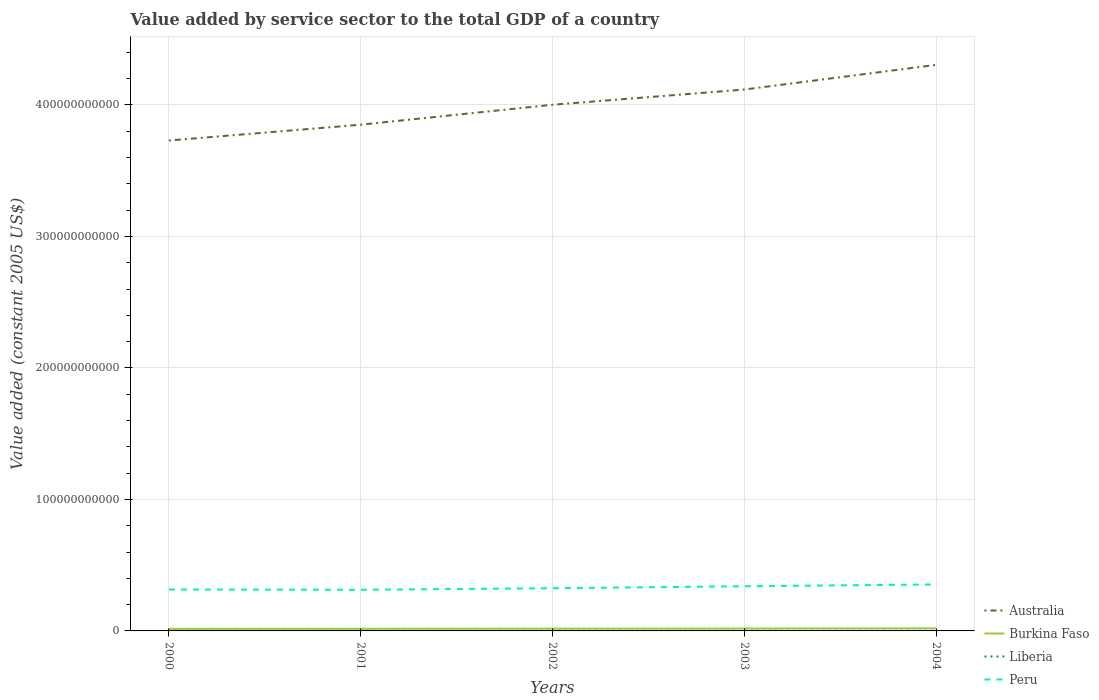Does the line corresponding to Peru intersect with the line corresponding to Australia?
Ensure brevity in your answer.  No. Is the number of lines equal to the number of legend labels?
Keep it short and to the point. Yes. Across all years, what is the maximum value added by service sector in Liberia?
Provide a succinct answer. 1.06e+08. In which year was the value added by service sector in Liberia maximum?
Your response must be concise. 2001. What is the total value added by service sector in Burkina Faso in the graph?
Offer a terse response. -5.86e+07. What is the difference between the highest and the second highest value added by service sector in Australia?
Offer a very short reply. 5.75e+1. How many lines are there?
Keep it short and to the point. 4. What is the difference between two consecutive major ticks on the Y-axis?
Ensure brevity in your answer.  1.00e+11. Are the values on the major ticks of Y-axis written in scientific E-notation?
Provide a succinct answer. No. Does the graph contain any zero values?
Offer a terse response. No. Does the graph contain grids?
Provide a short and direct response. Yes. Where does the legend appear in the graph?
Your answer should be compact. Bottom right. How many legend labels are there?
Your answer should be very brief. 4. How are the legend labels stacked?
Your answer should be compact. Vertical. What is the title of the graph?
Provide a short and direct response. Value added by service sector to the total GDP of a country. What is the label or title of the X-axis?
Your answer should be compact. Years. What is the label or title of the Y-axis?
Your answer should be compact. Value added (constant 2005 US$). What is the Value added (constant 2005 US$) in Australia in 2000?
Make the answer very short. 3.73e+11. What is the Value added (constant 2005 US$) of Burkina Faso in 2000?
Provide a short and direct response. 1.56e+09. What is the Value added (constant 2005 US$) in Liberia in 2000?
Your answer should be very brief. 1.07e+08. What is the Value added (constant 2005 US$) of Peru in 2000?
Offer a very short reply. 3.15e+1. What is the Value added (constant 2005 US$) in Australia in 2001?
Ensure brevity in your answer.  3.85e+11. What is the Value added (constant 2005 US$) of Burkina Faso in 2001?
Provide a short and direct response. 1.62e+09. What is the Value added (constant 2005 US$) in Liberia in 2001?
Provide a succinct answer. 1.06e+08. What is the Value added (constant 2005 US$) of Peru in 2001?
Offer a terse response. 3.13e+1. What is the Value added (constant 2005 US$) in Australia in 2002?
Ensure brevity in your answer.  4.00e+11. What is the Value added (constant 2005 US$) of Burkina Faso in 2002?
Provide a succinct answer. 1.76e+09. What is the Value added (constant 2005 US$) of Liberia in 2002?
Ensure brevity in your answer.  1.13e+08. What is the Value added (constant 2005 US$) in Peru in 2002?
Your answer should be very brief. 3.25e+1. What is the Value added (constant 2005 US$) in Australia in 2003?
Offer a terse response. 4.12e+11. What is the Value added (constant 2005 US$) in Burkina Faso in 2003?
Your response must be concise. 1.81e+09. What is the Value added (constant 2005 US$) in Liberia in 2003?
Your response must be concise. 1.11e+08. What is the Value added (constant 2005 US$) of Peru in 2003?
Make the answer very short. 3.40e+1. What is the Value added (constant 2005 US$) in Australia in 2004?
Ensure brevity in your answer.  4.31e+11. What is the Value added (constant 2005 US$) of Burkina Faso in 2004?
Provide a short and direct response. 1.97e+09. What is the Value added (constant 2005 US$) in Liberia in 2004?
Make the answer very short. 1.35e+08. What is the Value added (constant 2005 US$) in Peru in 2004?
Your answer should be compact. 3.53e+1. Across all years, what is the maximum Value added (constant 2005 US$) of Australia?
Keep it short and to the point. 4.31e+11. Across all years, what is the maximum Value added (constant 2005 US$) of Burkina Faso?
Provide a short and direct response. 1.97e+09. Across all years, what is the maximum Value added (constant 2005 US$) of Liberia?
Your answer should be compact. 1.35e+08. Across all years, what is the maximum Value added (constant 2005 US$) in Peru?
Ensure brevity in your answer.  3.53e+1. Across all years, what is the minimum Value added (constant 2005 US$) of Australia?
Make the answer very short. 3.73e+11. Across all years, what is the minimum Value added (constant 2005 US$) in Burkina Faso?
Your answer should be very brief. 1.56e+09. Across all years, what is the minimum Value added (constant 2005 US$) of Liberia?
Your response must be concise. 1.06e+08. Across all years, what is the minimum Value added (constant 2005 US$) of Peru?
Make the answer very short. 3.13e+1. What is the total Value added (constant 2005 US$) of Australia in the graph?
Offer a terse response. 2.00e+12. What is the total Value added (constant 2005 US$) in Burkina Faso in the graph?
Your answer should be compact. 8.73e+09. What is the total Value added (constant 2005 US$) of Liberia in the graph?
Offer a terse response. 5.72e+08. What is the total Value added (constant 2005 US$) of Peru in the graph?
Your answer should be very brief. 1.65e+11. What is the difference between the Value added (constant 2005 US$) in Australia in 2000 and that in 2001?
Your answer should be compact. -1.20e+1. What is the difference between the Value added (constant 2005 US$) in Burkina Faso in 2000 and that in 2001?
Provide a short and direct response. -5.86e+07. What is the difference between the Value added (constant 2005 US$) of Liberia in 2000 and that in 2001?
Keep it short and to the point. 1.25e+06. What is the difference between the Value added (constant 2005 US$) in Peru in 2000 and that in 2001?
Offer a terse response. 2.14e+08. What is the difference between the Value added (constant 2005 US$) of Australia in 2000 and that in 2002?
Ensure brevity in your answer.  -2.72e+1. What is the difference between the Value added (constant 2005 US$) in Burkina Faso in 2000 and that in 2002?
Make the answer very short. -1.97e+08. What is the difference between the Value added (constant 2005 US$) of Liberia in 2000 and that in 2002?
Your answer should be very brief. -6.06e+06. What is the difference between the Value added (constant 2005 US$) in Peru in 2000 and that in 2002?
Give a very brief answer. -9.56e+08. What is the difference between the Value added (constant 2005 US$) of Australia in 2000 and that in 2003?
Offer a very short reply. -3.88e+1. What is the difference between the Value added (constant 2005 US$) of Burkina Faso in 2000 and that in 2003?
Ensure brevity in your answer.  -2.41e+08. What is the difference between the Value added (constant 2005 US$) in Liberia in 2000 and that in 2003?
Your answer should be very brief. -4.32e+06. What is the difference between the Value added (constant 2005 US$) of Peru in 2000 and that in 2003?
Keep it short and to the point. -2.47e+09. What is the difference between the Value added (constant 2005 US$) of Australia in 2000 and that in 2004?
Ensure brevity in your answer.  -5.75e+1. What is the difference between the Value added (constant 2005 US$) in Burkina Faso in 2000 and that in 2004?
Offer a terse response. -4.10e+08. What is the difference between the Value added (constant 2005 US$) of Liberia in 2000 and that in 2004?
Keep it short and to the point. -2.82e+07. What is the difference between the Value added (constant 2005 US$) in Peru in 2000 and that in 2004?
Keep it short and to the point. -3.83e+09. What is the difference between the Value added (constant 2005 US$) of Australia in 2001 and that in 2002?
Your answer should be very brief. -1.52e+1. What is the difference between the Value added (constant 2005 US$) of Burkina Faso in 2001 and that in 2002?
Your answer should be very brief. -1.38e+08. What is the difference between the Value added (constant 2005 US$) in Liberia in 2001 and that in 2002?
Offer a terse response. -7.32e+06. What is the difference between the Value added (constant 2005 US$) of Peru in 2001 and that in 2002?
Provide a succinct answer. -1.17e+09. What is the difference between the Value added (constant 2005 US$) in Australia in 2001 and that in 2003?
Offer a very short reply. -2.67e+1. What is the difference between the Value added (constant 2005 US$) in Burkina Faso in 2001 and that in 2003?
Offer a terse response. -1.83e+08. What is the difference between the Value added (constant 2005 US$) of Liberia in 2001 and that in 2003?
Offer a terse response. -5.58e+06. What is the difference between the Value added (constant 2005 US$) of Peru in 2001 and that in 2003?
Offer a terse response. -2.69e+09. What is the difference between the Value added (constant 2005 US$) in Australia in 2001 and that in 2004?
Offer a very short reply. -4.55e+1. What is the difference between the Value added (constant 2005 US$) of Burkina Faso in 2001 and that in 2004?
Keep it short and to the point. -3.51e+08. What is the difference between the Value added (constant 2005 US$) in Liberia in 2001 and that in 2004?
Offer a very short reply. -2.94e+07. What is the difference between the Value added (constant 2005 US$) in Peru in 2001 and that in 2004?
Your answer should be compact. -4.05e+09. What is the difference between the Value added (constant 2005 US$) in Australia in 2002 and that in 2003?
Give a very brief answer. -1.16e+1. What is the difference between the Value added (constant 2005 US$) of Burkina Faso in 2002 and that in 2003?
Keep it short and to the point. -4.45e+07. What is the difference between the Value added (constant 2005 US$) in Liberia in 2002 and that in 2003?
Your answer should be compact. 1.74e+06. What is the difference between the Value added (constant 2005 US$) of Peru in 2002 and that in 2003?
Keep it short and to the point. -1.52e+09. What is the difference between the Value added (constant 2005 US$) of Australia in 2002 and that in 2004?
Provide a short and direct response. -3.03e+1. What is the difference between the Value added (constant 2005 US$) of Burkina Faso in 2002 and that in 2004?
Make the answer very short. -2.13e+08. What is the difference between the Value added (constant 2005 US$) of Liberia in 2002 and that in 2004?
Offer a terse response. -2.21e+07. What is the difference between the Value added (constant 2005 US$) in Peru in 2002 and that in 2004?
Ensure brevity in your answer.  -2.88e+09. What is the difference between the Value added (constant 2005 US$) of Australia in 2003 and that in 2004?
Give a very brief answer. -1.88e+1. What is the difference between the Value added (constant 2005 US$) of Burkina Faso in 2003 and that in 2004?
Your answer should be very brief. -1.68e+08. What is the difference between the Value added (constant 2005 US$) in Liberia in 2003 and that in 2004?
Keep it short and to the point. -2.39e+07. What is the difference between the Value added (constant 2005 US$) of Peru in 2003 and that in 2004?
Provide a succinct answer. -1.36e+09. What is the difference between the Value added (constant 2005 US$) in Australia in 2000 and the Value added (constant 2005 US$) in Burkina Faso in 2001?
Provide a short and direct response. 3.71e+11. What is the difference between the Value added (constant 2005 US$) in Australia in 2000 and the Value added (constant 2005 US$) in Liberia in 2001?
Provide a succinct answer. 3.73e+11. What is the difference between the Value added (constant 2005 US$) in Australia in 2000 and the Value added (constant 2005 US$) in Peru in 2001?
Make the answer very short. 3.42e+11. What is the difference between the Value added (constant 2005 US$) in Burkina Faso in 2000 and the Value added (constant 2005 US$) in Liberia in 2001?
Provide a short and direct response. 1.46e+09. What is the difference between the Value added (constant 2005 US$) in Burkina Faso in 2000 and the Value added (constant 2005 US$) in Peru in 2001?
Your response must be concise. -2.97e+1. What is the difference between the Value added (constant 2005 US$) in Liberia in 2000 and the Value added (constant 2005 US$) in Peru in 2001?
Provide a succinct answer. -3.12e+1. What is the difference between the Value added (constant 2005 US$) of Australia in 2000 and the Value added (constant 2005 US$) of Burkina Faso in 2002?
Provide a short and direct response. 3.71e+11. What is the difference between the Value added (constant 2005 US$) in Australia in 2000 and the Value added (constant 2005 US$) in Liberia in 2002?
Provide a succinct answer. 3.73e+11. What is the difference between the Value added (constant 2005 US$) of Australia in 2000 and the Value added (constant 2005 US$) of Peru in 2002?
Ensure brevity in your answer.  3.41e+11. What is the difference between the Value added (constant 2005 US$) of Burkina Faso in 2000 and the Value added (constant 2005 US$) of Liberia in 2002?
Offer a very short reply. 1.45e+09. What is the difference between the Value added (constant 2005 US$) in Burkina Faso in 2000 and the Value added (constant 2005 US$) in Peru in 2002?
Ensure brevity in your answer.  -3.09e+1. What is the difference between the Value added (constant 2005 US$) in Liberia in 2000 and the Value added (constant 2005 US$) in Peru in 2002?
Provide a short and direct response. -3.24e+1. What is the difference between the Value added (constant 2005 US$) of Australia in 2000 and the Value added (constant 2005 US$) of Burkina Faso in 2003?
Your response must be concise. 3.71e+11. What is the difference between the Value added (constant 2005 US$) of Australia in 2000 and the Value added (constant 2005 US$) of Liberia in 2003?
Offer a terse response. 3.73e+11. What is the difference between the Value added (constant 2005 US$) in Australia in 2000 and the Value added (constant 2005 US$) in Peru in 2003?
Give a very brief answer. 3.39e+11. What is the difference between the Value added (constant 2005 US$) in Burkina Faso in 2000 and the Value added (constant 2005 US$) in Liberia in 2003?
Offer a very short reply. 1.45e+09. What is the difference between the Value added (constant 2005 US$) of Burkina Faso in 2000 and the Value added (constant 2005 US$) of Peru in 2003?
Offer a very short reply. -3.24e+1. What is the difference between the Value added (constant 2005 US$) in Liberia in 2000 and the Value added (constant 2005 US$) in Peru in 2003?
Provide a succinct answer. -3.39e+1. What is the difference between the Value added (constant 2005 US$) in Australia in 2000 and the Value added (constant 2005 US$) in Burkina Faso in 2004?
Ensure brevity in your answer.  3.71e+11. What is the difference between the Value added (constant 2005 US$) of Australia in 2000 and the Value added (constant 2005 US$) of Liberia in 2004?
Your response must be concise. 3.73e+11. What is the difference between the Value added (constant 2005 US$) in Australia in 2000 and the Value added (constant 2005 US$) in Peru in 2004?
Your response must be concise. 3.38e+11. What is the difference between the Value added (constant 2005 US$) in Burkina Faso in 2000 and the Value added (constant 2005 US$) in Liberia in 2004?
Ensure brevity in your answer.  1.43e+09. What is the difference between the Value added (constant 2005 US$) in Burkina Faso in 2000 and the Value added (constant 2005 US$) in Peru in 2004?
Offer a very short reply. -3.38e+1. What is the difference between the Value added (constant 2005 US$) in Liberia in 2000 and the Value added (constant 2005 US$) in Peru in 2004?
Ensure brevity in your answer.  -3.52e+1. What is the difference between the Value added (constant 2005 US$) in Australia in 2001 and the Value added (constant 2005 US$) in Burkina Faso in 2002?
Provide a succinct answer. 3.83e+11. What is the difference between the Value added (constant 2005 US$) of Australia in 2001 and the Value added (constant 2005 US$) of Liberia in 2002?
Make the answer very short. 3.85e+11. What is the difference between the Value added (constant 2005 US$) in Australia in 2001 and the Value added (constant 2005 US$) in Peru in 2002?
Ensure brevity in your answer.  3.53e+11. What is the difference between the Value added (constant 2005 US$) of Burkina Faso in 2001 and the Value added (constant 2005 US$) of Liberia in 2002?
Make the answer very short. 1.51e+09. What is the difference between the Value added (constant 2005 US$) of Burkina Faso in 2001 and the Value added (constant 2005 US$) of Peru in 2002?
Make the answer very short. -3.08e+1. What is the difference between the Value added (constant 2005 US$) in Liberia in 2001 and the Value added (constant 2005 US$) in Peru in 2002?
Make the answer very short. -3.24e+1. What is the difference between the Value added (constant 2005 US$) in Australia in 2001 and the Value added (constant 2005 US$) in Burkina Faso in 2003?
Your answer should be very brief. 3.83e+11. What is the difference between the Value added (constant 2005 US$) in Australia in 2001 and the Value added (constant 2005 US$) in Liberia in 2003?
Offer a very short reply. 3.85e+11. What is the difference between the Value added (constant 2005 US$) of Australia in 2001 and the Value added (constant 2005 US$) of Peru in 2003?
Offer a very short reply. 3.51e+11. What is the difference between the Value added (constant 2005 US$) in Burkina Faso in 2001 and the Value added (constant 2005 US$) in Liberia in 2003?
Ensure brevity in your answer.  1.51e+09. What is the difference between the Value added (constant 2005 US$) in Burkina Faso in 2001 and the Value added (constant 2005 US$) in Peru in 2003?
Your response must be concise. -3.24e+1. What is the difference between the Value added (constant 2005 US$) in Liberia in 2001 and the Value added (constant 2005 US$) in Peru in 2003?
Make the answer very short. -3.39e+1. What is the difference between the Value added (constant 2005 US$) in Australia in 2001 and the Value added (constant 2005 US$) in Burkina Faso in 2004?
Provide a succinct answer. 3.83e+11. What is the difference between the Value added (constant 2005 US$) of Australia in 2001 and the Value added (constant 2005 US$) of Liberia in 2004?
Your answer should be very brief. 3.85e+11. What is the difference between the Value added (constant 2005 US$) of Australia in 2001 and the Value added (constant 2005 US$) of Peru in 2004?
Offer a very short reply. 3.50e+11. What is the difference between the Value added (constant 2005 US$) of Burkina Faso in 2001 and the Value added (constant 2005 US$) of Liberia in 2004?
Offer a very short reply. 1.49e+09. What is the difference between the Value added (constant 2005 US$) of Burkina Faso in 2001 and the Value added (constant 2005 US$) of Peru in 2004?
Ensure brevity in your answer.  -3.37e+1. What is the difference between the Value added (constant 2005 US$) in Liberia in 2001 and the Value added (constant 2005 US$) in Peru in 2004?
Provide a succinct answer. -3.52e+1. What is the difference between the Value added (constant 2005 US$) in Australia in 2002 and the Value added (constant 2005 US$) in Burkina Faso in 2003?
Make the answer very short. 3.98e+11. What is the difference between the Value added (constant 2005 US$) in Australia in 2002 and the Value added (constant 2005 US$) in Liberia in 2003?
Offer a terse response. 4.00e+11. What is the difference between the Value added (constant 2005 US$) of Australia in 2002 and the Value added (constant 2005 US$) of Peru in 2003?
Your answer should be compact. 3.66e+11. What is the difference between the Value added (constant 2005 US$) in Burkina Faso in 2002 and the Value added (constant 2005 US$) in Liberia in 2003?
Give a very brief answer. 1.65e+09. What is the difference between the Value added (constant 2005 US$) in Burkina Faso in 2002 and the Value added (constant 2005 US$) in Peru in 2003?
Ensure brevity in your answer.  -3.22e+1. What is the difference between the Value added (constant 2005 US$) of Liberia in 2002 and the Value added (constant 2005 US$) of Peru in 2003?
Offer a very short reply. -3.39e+1. What is the difference between the Value added (constant 2005 US$) of Australia in 2002 and the Value added (constant 2005 US$) of Burkina Faso in 2004?
Your answer should be very brief. 3.98e+11. What is the difference between the Value added (constant 2005 US$) of Australia in 2002 and the Value added (constant 2005 US$) of Liberia in 2004?
Provide a succinct answer. 4.00e+11. What is the difference between the Value added (constant 2005 US$) of Australia in 2002 and the Value added (constant 2005 US$) of Peru in 2004?
Offer a terse response. 3.65e+11. What is the difference between the Value added (constant 2005 US$) in Burkina Faso in 2002 and the Value added (constant 2005 US$) in Liberia in 2004?
Give a very brief answer. 1.63e+09. What is the difference between the Value added (constant 2005 US$) of Burkina Faso in 2002 and the Value added (constant 2005 US$) of Peru in 2004?
Keep it short and to the point. -3.36e+1. What is the difference between the Value added (constant 2005 US$) in Liberia in 2002 and the Value added (constant 2005 US$) in Peru in 2004?
Provide a succinct answer. -3.52e+1. What is the difference between the Value added (constant 2005 US$) of Australia in 2003 and the Value added (constant 2005 US$) of Burkina Faso in 2004?
Provide a succinct answer. 4.10e+11. What is the difference between the Value added (constant 2005 US$) of Australia in 2003 and the Value added (constant 2005 US$) of Liberia in 2004?
Your answer should be compact. 4.12e+11. What is the difference between the Value added (constant 2005 US$) in Australia in 2003 and the Value added (constant 2005 US$) in Peru in 2004?
Ensure brevity in your answer.  3.76e+11. What is the difference between the Value added (constant 2005 US$) in Burkina Faso in 2003 and the Value added (constant 2005 US$) in Liberia in 2004?
Your answer should be very brief. 1.67e+09. What is the difference between the Value added (constant 2005 US$) in Burkina Faso in 2003 and the Value added (constant 2005 US$) in Peru in 2004?
Ensure brevity in your answer.  -3.35e+1. What is the difference between the Value added (constant 2005 US$) in Liberia in 2003 and the Value added (constant 2005 US$) in Peru in 2004?
Provide a succinct answer. -3.52e+1. What is the average Value added (constant 2005 US$) of Australia per year?
Your answer should be compact. 4.00e+11. What is the average Value added (constant 2005 US$) of Burkina Faso per year?
Offer a very short reply. 1.75e+09. What is the average Value added (constant 2005 US$) of Liberia per year?
Give a very brief answer. 1.14e+08. What is the average Value added (constant 2005 US$) in Peru per year?
Your answer should be very brief. 3.29e+1. In the year 2000, what is the difference between the Value added (constant 2005 US$) in Australia and Value added (constant 2005 US$) in Burkina Faso?
Make the answer very short. 3.71e+11. In the year 2000, what is the difference between the Value added (constant 2005 US$) in Australia and Value added (constant 2005 US$) in Liberia?
Your answer should be compact. 3.73e+11. In the year 2000, what is the difference between the Value added (constant 2005 US$) of Australia and Value added (constant 2005 US$) of Peru?
Offer a very short reply. 3.41e+11. In the year 2000, what is the difference between the Value added (constant 2005 US$) of Burkina Faso and Value added (constant 2005 US$) of Liberia?
Keep it short and to the point. 1.46e+09. In the year 2000, what is the difference between the Value added (constant 2005 US$) in Burkina Faso and Value added (constant 2005 US$) in Peru?
Your answer should be very brief. -2.99e+1. In the year 2000, what is the difference between the Value added (constant 2005 US$) of Liberia and Value added (constant 2005 US$) of Peru?
Provide a short and direct response. -3.14e+1. In the year 2001, what is the difference between the Value added (constant 2005 US$) in Australia and Value added (constant 2005 US$) in Burkina Faso?
Your answer should be very brief. 3.83e+11. In the year 2001, what is the difference between the Value added (constant 2005 US$) of Australia and Value added (constant 2005 US$) of Liberia?
Ensure brevity in your answer.  3.85e+11. In the year 2001, what is the difference between the Value added (constant 2005 US$) of Australia and Value added (constant 2005 US$) of Peru?
Your answer should be very brief. 3.54e+11. In the year 2001, what is the difference between the Value added (constant 2005 US$) of Burkina Faso and Value added (constant 2005 US$) of Liberia?
Ensure brevity in your answer.  1.52e+09. In the year 2001, what is the difference between the Value added (constant 2005 US$) in Burkina Faso and Value added (constant 2005 US$) in Peru?
Your response must be concise. -2.97e+1. In the year 2001, what is the difference between the Value added (constant 2005 US$) in Liberia and Value added (constant 2005 US$) in Peru?
Keep it short and to the point. -3.12e+1. In the year 2002, what is the difference between the Value added (constant 2005 US$) of Australia and Value added (constant 2005 US$) of Burkina Faso?
Give a very brief answer. 3.98e+11. In the year 2002, what is the difference between the Value added (constant 2005 US$) of Australia and Value added (constant 2005 US$) of Liberia?
Offer a terse response. 4.00e+11. In the year 2002, what is the difference between the Value added (constant 2005 US$) of Australia and Value added (constant 2005 US$) of Peru?
Your answer should be compact. 3.68e+11. In the year 2002, what is the difference between the Value added (constant 2005 US$) of Burkina Faso and Value added (constant 2005 US$) of Liberia?
Offer a terse response. 1.65e+09. In the year 2002, what is the difference between the Value added (constant 2005 US$) of Burkina Faso and Value added (constant 2005 US$) of Peru?
Your response must be concise. -3.07e+1. In the year 2002, what is the difference between the Value added (constant 2005 US$) of Liberia and Value added (constant 2005 US$) of Peru?
Your response must be concise. -3.23e+1. In the year 2003, what is the difference between the Value added (constant 2005 US$) of Australia and Value added (constant 2005 US$) of Burkina Faso?
Provide a short and direct response. 4.10e+11. In the year 2003, what is the difference between the Value added (constant 2005 US$) in Australia and Value added (constant 2005 US$) in Liberia?
Offer a very short reply. 4.12e+11. In the year 2003, what is the difference between the Value added (constant 2005 US$) of Australia and Value added (constant 2005 US$) of Peru?
Ensure brevity in your answer.  3.78e+11. In the year 2003, what is the difference between the Value added (constant 2005 US$) in Burkina Faso and Value added (constant 2005 US$) in Liberia?
Your answer should be compact. 1.69e+09. In the year 2003, what is the difference between the Value added (constant 2005 US$) of Burkina Faso and Value added (constant 2005 US$) of Peru?
Give a very brief answer. -3.22e+1. In the year 2003, what is the difference between the Value added (constant 2005 US$) in Liberia and Value added (constant 2005 US$) in Peru?
Your answer should be very brief. -3.39e+1. In the year 2004, what is the difference between the Value added (constant 2005 US$) of Australia and Value added (constant 2005 US$) of Burkina Faso?
Your answer should be very brief. 4.29e+11. In the year 2004, what is the difference between the Value added (constant 2005 US$) of Australia and Value added (constant 2005 US$) of Liberia?
Provide a succinct answer. 4.30e+11. In the year 2004, what is the difference between the Value added (constant 2005 US$) in Australia and Value added (constant 2005 US$) in Peru?
Give a very brief answer. 3.95e+11. In the year 2004, what is the difference between the Value added (constant 2005 US$) in Burkina Faso and Value added (constant 2005 US$) in Liberia?
Provide a short and direct response. 1.84e+09. In the year 2004, what is the difference between the Value added (constant 2005 US$) of Burkina Faso and Value added (constant 2005 US$) of Peru?
Keep it short and to the point. -3.34e+1. In the year 2004, what is the difference between the Value added (constant 2005 US$) in Liberia and Value added (constant 2005 US$) in Peru?
Ensure brevity in your answer.  -3.52e+1. What is the ratio of the Value added (constant 2005 US$) in Australia in 2000 to that in 2001?
Ensure brevity in your answer.  0.97. What is the ratio of the Value added (constant 2005 US$) in Burkina Faso in 2000 to that in 2001?
Give a very brief answer. 0.96. What is the ratio of the Value added (constant 2005 US$) in Liberia in 2000 to that in 2001?
Offer a terse response. 1.01. What is the ratio of the Value added (constant 2005 US$) in Peru in 2000 to that in 2001?
Your response must be concise. 1.01. What is the ratio of the Value added (constant 2005 US$) in Australia in 2000 to that in 2002?
Provide a succinct answer. 0.93. What is the ratio of the Value added (constant 2005 US$) in Burkina Faso in 2000 to that in 2002?
Give a very brief answer. 0.89. What is the ratio of the Value added (constant 2005 US$) in Liberia in 2000 to that in 2002?
Your answer should be very brief. 0.95. What is the ratio of the Value added (constant 2005 US$) of Peru in 2000 to that in 2002?
Your answer should be compact. 0.97. What is the ratio of the Value added (constant 2005 US$) in Australia in 2000 to that in 2003?
Offer a terse response. 0.91. What is the ratio of the Value added (constant 2005 US$) in Burkina Faso in 2000 to that in 2003?
Keep it short and to the point. 0.87. What is the ratio of the Value added (constant 2005 US$) of Liberia in 2000 to that in 2003?
Your response must be concise. 0.96. What is the ratio of the Value added (constant 2005 US$) in Peru in 2000 to that in 2003?
Make the answer very short. 0.93. What is the ratio of the Value added (constant 2005 US$) in Australia in 2000 to that in 2004?
Ensure brevity in your answer.  0.87. What is the ratio of the Value added (constant 2005 US$) in Burkina Faso in 2000 to that in 2004?
Your answer should be compact. 0.79. What is the ratio of the Value added (constant 2005 US$) in Liberia in 2000 to that in 2004?
Offer a terse response. 0.79. What is the ratio of the Value added (constant 2005 US$) in Peru in 2000 to that in 2004?
Offer a terse response. 0.89. What is the ratio of the Value added (constant 2005 US$) in Australia in 2001 to that in 2002?
Your answer should be compact. 0.96. What is the ratio of the Value added (constant 2005 US$) in Burkina Faso in 2001 to that in 2002?
Provide a short and direct response. 0.92. What is the ratio of the Value added (constant 2005 US$) in Liberia in 2001 to that in 2002?
Make the answer very short. 0.94. What is the ratio of the Value added (constant 2005 US$) of Peru in 2001 to that in 2002?
Make the answer very short. 0.96. What is the ratio of the Value added (constant 2005 US$) of Australia in 2001 to that in 2003?
Keep it short and to the point. 0.94. What is the ratio of the Value added (constant 2005 US$) in Burkina Faso in 2001 to that in 2003?
Keep it short and to the point. 0.9. What is the ratio of the Value added (constant 2005 US$) in Liberia in 2001 to that in 2003?
Your response must be concise. 0.95. What is the ratio of the Value added (constant 2005 US$) in Peru in 2001 to that in 2003?
Give a very brief answer. 0.92. What is the ratio of the Value added (constant 2005 US$) of Australia in 2001 to that in 2004?
Keep it short and to the point. 0.89. What is the ratio of the Value added (constant 2005 US$) in Burkina Faso in 2001 to that in 2004?
Offer a very short reply. 0.82. What is the ratio of the Value added (constant 2005 US$) of Liberia in 2001 to that in 2004?
Your answer should be compact. 0.78. What is the ratio of the Value added (constant 2005 US$) of Peru in 2001 to that in 2004?
Provide a succinct answer. 0.89. What is the ratio of the Value added (constant 2005 US$) of Australia in 2002 to that in 2003?
Offer a very short reply. 0.97. What is the ratio of the Value added (constant 2005 US$) of Burkina Faso in 2002 to that in 2003?
Your answer should be very brief. 0.98. What is the ratio of the Value added (constant 2005 US$) in Liberia in 2002 to that in 2003?
Offer a terse response. 1.02. What is the ratio of the Value added (constant 2005 US$) of Peru in 2002 to that in 2003?
Your answer should be very brief. 0.96. What is the ratio of the Value added (constant 2005 US$) in Australia in 2002 to that in 2004?
Provide a succinct answer. 0.93. What is the ratio of the Value added (constant 2005 US$) in Burkina Faso in 2002 to that in 2004?
Keep it short and to the point. 0.89. What is the ratio of the Value added (constant 2005 US$) in Liberia in 2002 to that in 2004?
Provide a short and direct response. 0.84. What is the ratio of the Value added (constant 2005 US$) in Peru in 2002 to that in 2004?
Offer a terse response. 0.92. What is the ratio of the Value added (constant 2005 US$) of Australia in 2003 to that in 2004?
Your response must be concise. 0.96. What is the ratio of the Value added (constant 2005 US$) in Burkina Faso in 2003 to that in 2004?
Ensure brevity in your answer.  0.91. What is the ratio of the Value added (constant 2005 US$) in Liberia in 2003 to that in 2004?
Your response must be concise. 0.82. What is the ratio of the Value added (constant 2005 US$) of Peru in 2003 to that in 2004?
Keep it short and to the point. 0.96. What is the difference between the highest and the second highest Value added (constant 2005 US$) of Australia?
Your answer should be very brief. 1.88e+1. What is the difference between the highest and the second highest Value added (constant 2005 US$) in Burkina Faso?
Your answer should be very brief. 1.68e+08. What is the difference between the highest and the second highest Value added (constant 2005 US$) of Liberia?
Make the answer very short. 2.21e+07. What is the difference between the highest and the second highest Value added (constant 2005 US$) of Peru?
Give a very brief answer. 1.36e+09. What is the difference between the highest and the lowest Value added (constant 2005 US$) in Australia?
Ensure brevity in your answer.  5.75e+1. What is the difference between the highest and the lowest Value added (constant 2005 US$) in Burkina Faso?
Your answer should be compact. 4.10e+08. What is the difference between the highest and the lowest Value added (constant 2005 US$) in Liberia?
Keep it short and to the point. 2.94e+07. What is the difference between the highest and the lowest Value added (constant 2005 US$) of Peru?
Provide a succinct answer. 4.05e+09. 